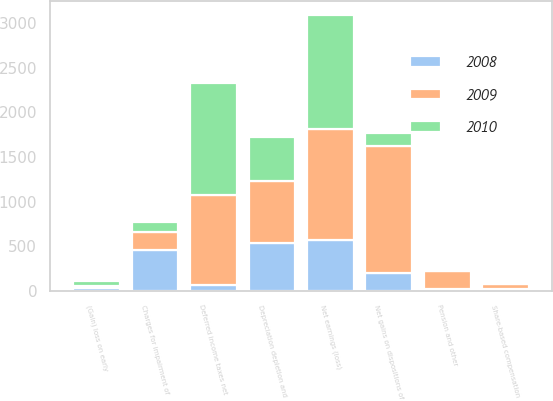<chart> <loc_0><loc_0><loc_500><loc_500><stacked_bar_chart><ecel><fcel>Net earnings (loss)<fcel>Depreciation depletion and<fcel>Deferred income taxes net<fcel>Pension and other<fcel>Share-based compensation<fcel>Charges for impairment of<fcel>Net gains on dispositions of<fcel>(Gain) loss on early<nl><fcel>2010<fcel>1283<fcel>503<fcel>1257<fcel>21<fcel>24<fcel>117<fcel>149<fcel>50<nl><fcel>2008<fcel>568<fcel>538<fcel>66<fcel>19<fcel>26<fcel>458<fcel>197<fcel>28<nl><fcel>2009<fcel>1242<fcel>689<fcel>1005<fcel>200<fcel>47<fcel>197<fcel>1422<fcel>32<nl></chart> 